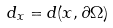Convert formula to latex. <formula><loc_0><loc_0><loc_500><loc_500>d _ { x } = d ( x , \partial \Omega )</formula> 